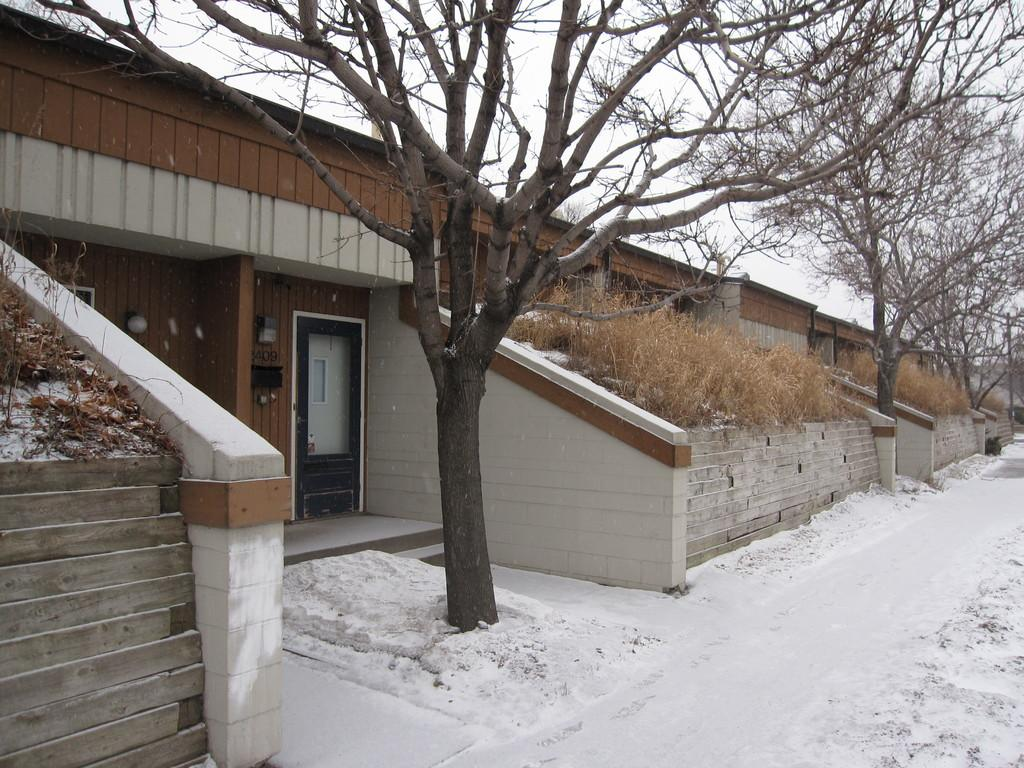What type of structure is present in the image? There is a house in the image. What are the main features of the house? The house has a roof, a door, and windows. What can be seen in the image besides the house? There are plants, trees, and the ground covered in snow in the image. What is visible in the background of the image? The sky is visible in the image. How many feet are visible on the ship in the image? There is no ship present in the image, so there are no feet visible on a ship. 